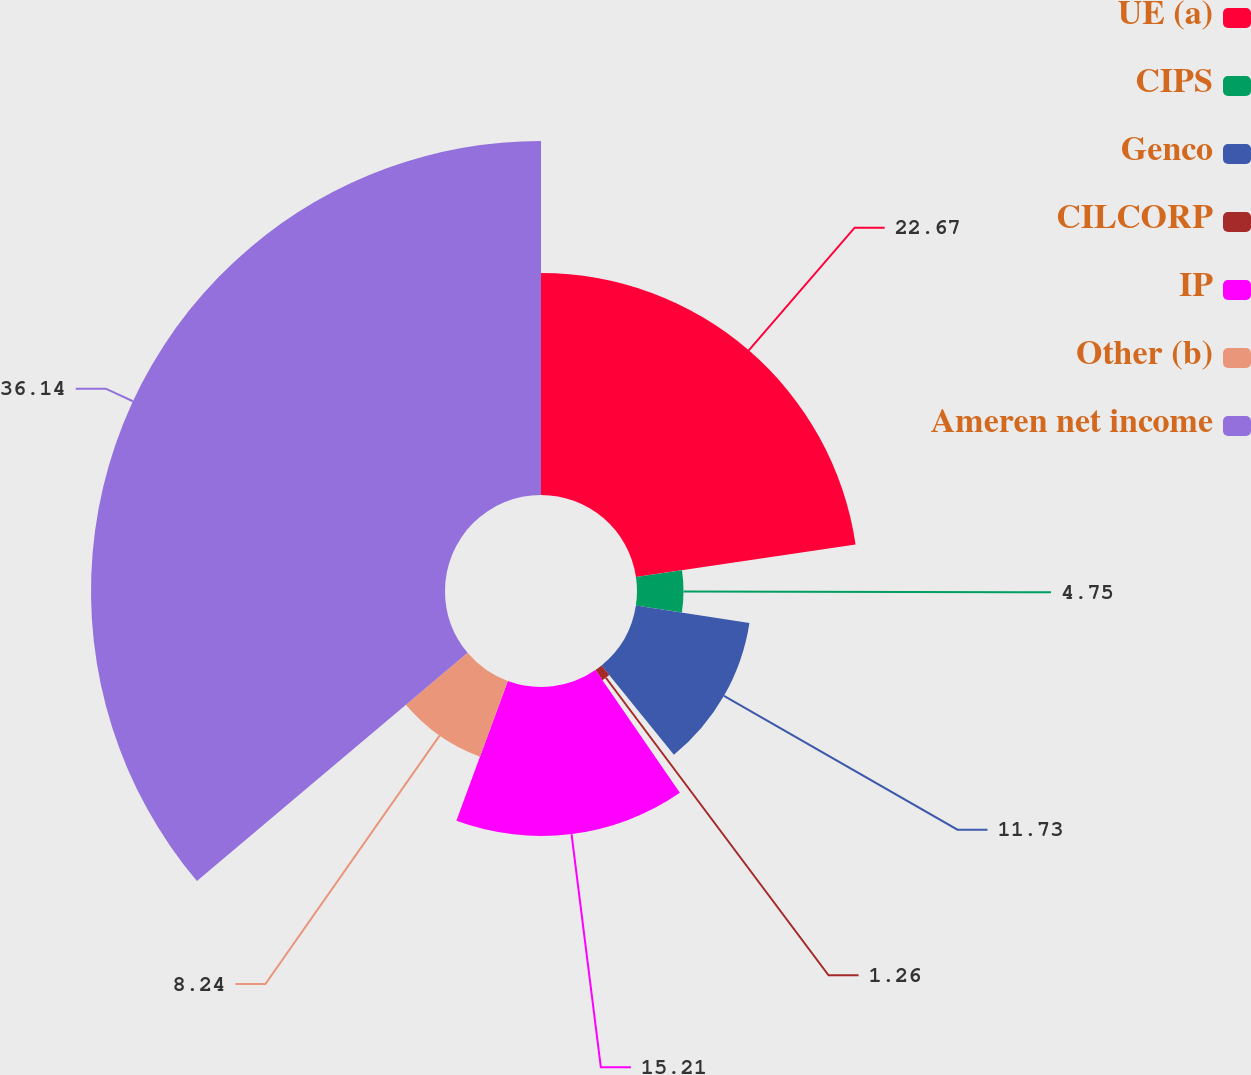Convert chart. <chart><loc_0><loc_0><loc_500><loc_500><pie_chart><fcel>UE (a)<fcel>CIPS<fcel>Genco<fcel>CILCORP<fcel>IP<fcel>Other (b)<fcel>Ameren net income<nl><fcel>22.67%<fcel>4.75%<fcel>11.73%<fcel>1.26%<fcel>15.21%<fcel>8.24%<fcel>36.15%<nl></chart> 